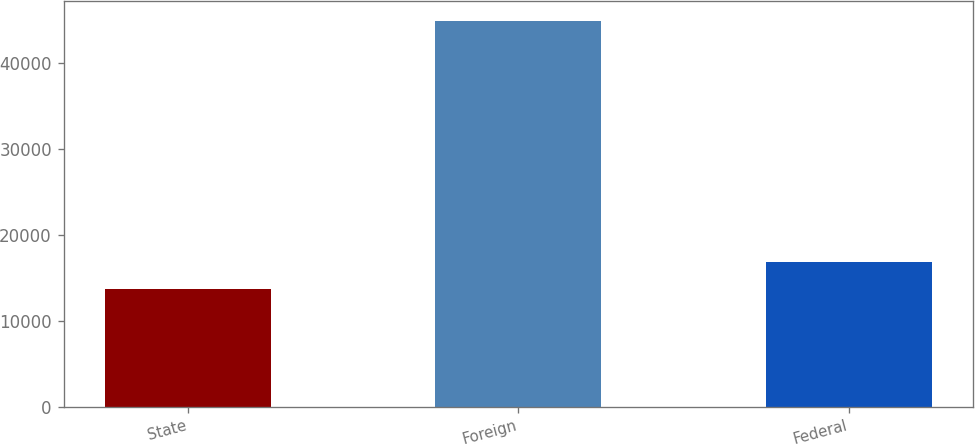<chart> <loc_0><loc_0><loc_500><loc_500><bar_chart><fcel>State<fcel>Foreign<fcel>Federal<nl><fcel>13731<fcel>44973<fcel>16855.2<nl></chart> 